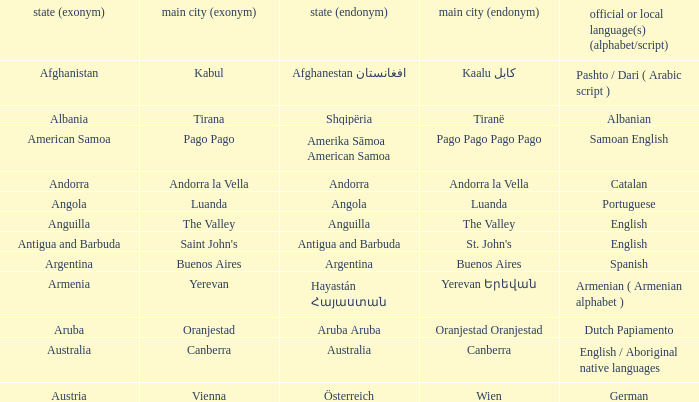What is the English name of the country whose official native language is Dutch Papiamento? Aruba. 